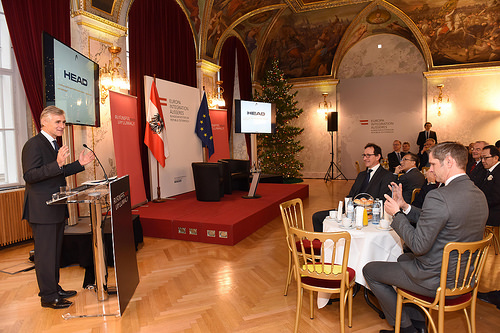<image>
Is the screen behind the chair? Yes. From this viewpoint, the screen is positioned behind the chair, with the chair partially or fully occluding the screen. Where is the board in relation to the man? Is it above the man? Yes. The board is positioned above the man in the vertical space, higher up in the scene. 